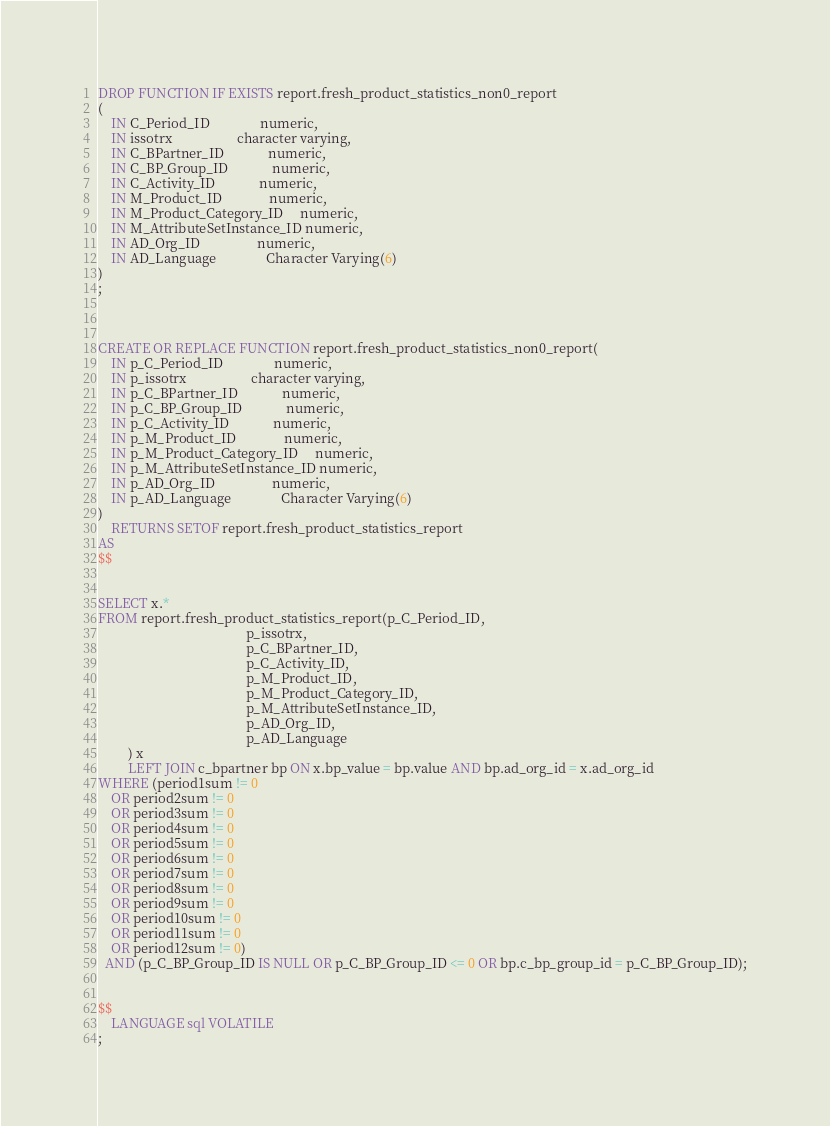<code> <loc_0><loc_0><loc_500><loc_500><_SQL_>DROP FUNCTION IF EXISTS report.fresh_product_statistics_non0_report
(
    IN C_Period_ID               numeric,
    IN issotrx                   character varying,
    IN C_BPartner_ID             numeric,
    IN C_BP_Group_ID             numeric,
    IN C_Activity_ID             numeric,
    IN M_Product_ID              numeric,
    IN M_Product_Category_ID     numeric,
    IN M_AttributeSetInstance_ID numeric,
    IN AD_Org_ID                 numeric,
    IN AD_Language               Character Varying(6)
)
;



CREATE OR REPLACE FUNCTION report.fresh_product_statistics_non0_report(
    IN p_C_Period_ID               numeric,
    IN p_issotrx                   character varying,
    IN p_C_BPartner_ID             numeric,
    IN p_C_BP_Group_ID             numeric,
    IN p_C_Activity_ID             numeric,
    IN p_M_Product_ID              numeric,
    IN p_M_Product_Category_ID     numeric,
    IN p_M_AttributeSetInstance_ID numeric,
    IN p_AD_Org_ID                 numeric,
    IN p_AD_Language               Character Varying(6)
)
    RETURNS SETOF report.fresh_product_statistics_report
AS
$$


SELECT x.*
FROM report.fresh_product_statistics_report(p_C_Period_ID,
                                            p_issotrx,
                                            p_C_BPartner_ID,
                                            p_C_Activity_ID,
                                            p_M_Product_ID,
                                            p_M_Product_Category_ID,
                                            p_M_AttributeSetInstance_ID,
                                            p_AD_Org_ID,
                                            p_AD_Language
         ) x
         LEFT JOIN c_bpartner bp ON x.bp_value = bp.value AND bp.ad_org_id = x.ad_org_id
WHERE (period1sum != 0
    OR period2sum != 0
    OR period3sum != 0
    OR period4sum != 0
    OR period5sum != 0
    OR period6sum != 0
    OR period7sum != 0
    OR period8sum != 0
    OR period9sum != 0
    OR period10sum != 0
    OR period11sum != 0
    OR period12sum != 0)
  AND (p_C_BP_Group_ID IS NULL OR p_C_BP_Group_ID <= 0 OR bp.c_bp_group_id = p_C_BP_Group_ID);


$$
    LANGUAGE sql VOLATILE
;</code> 